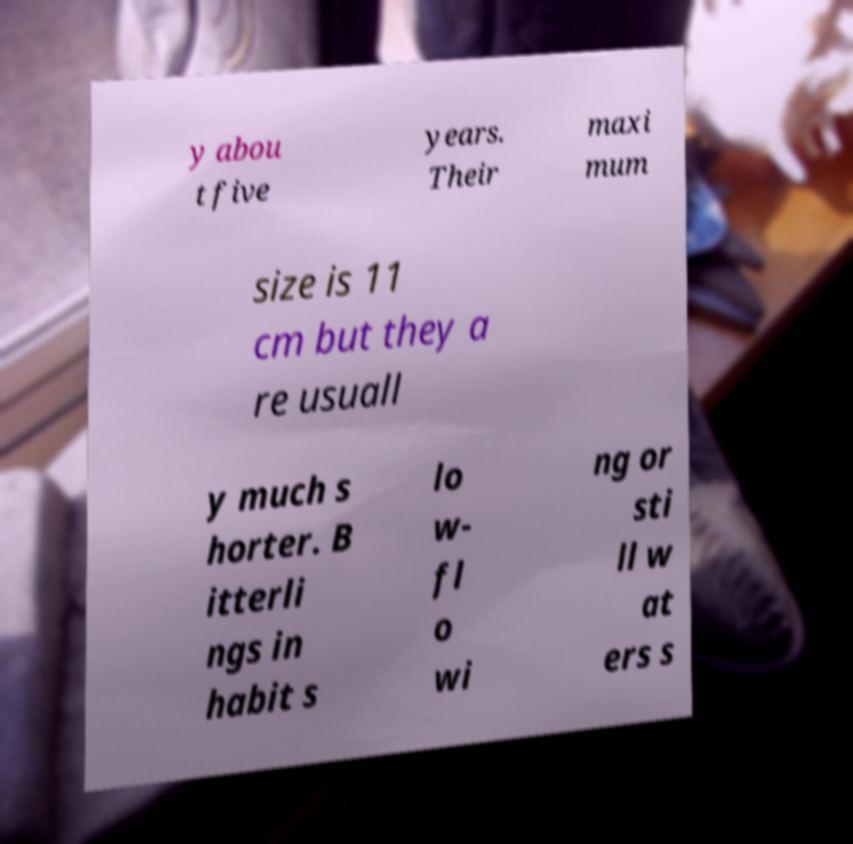For documentation purposes, I need the text within this image transcribed. Could you provide that? y abou t five years. Their maxi mum size is 11 cm but they a re usuall y much s horter. B itterli ngs in habit s lo w- fl o wi ng or sti ll w at ers s 